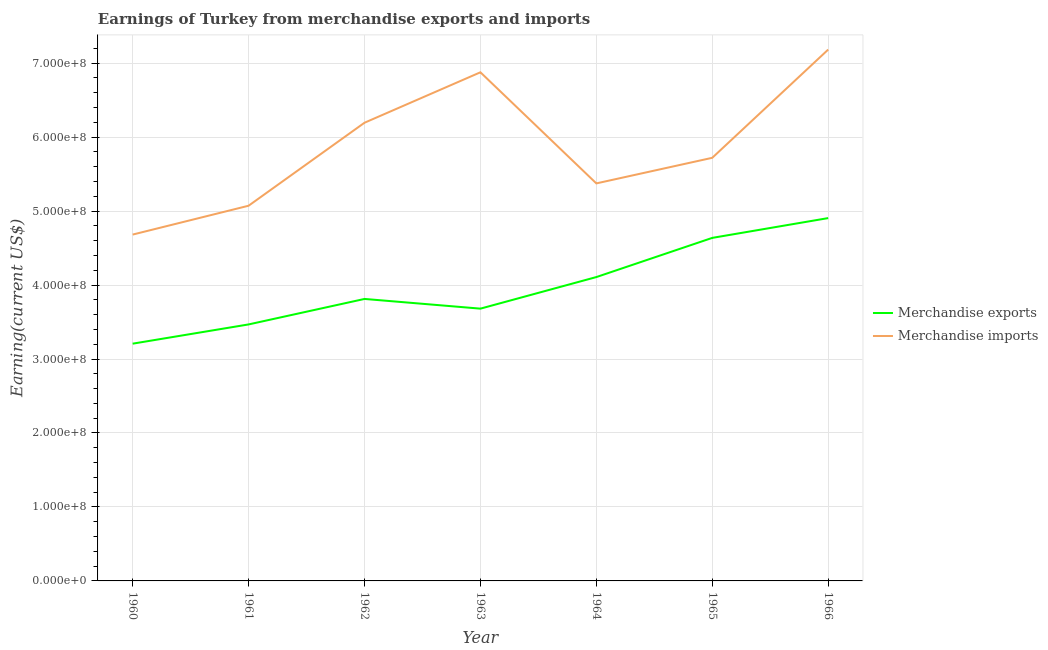Does the line corresponding to earnings from merchandise imports intersect with the line corresponding to earnings from merchandise exports?
Your answer should be very brief. No. Is the number of lines equal to the number of legend labels?
Offer a very short reply. Yes. What is the earnings from merchandise imports in 1963?
Keep it short and to the point. 6.88e+08. Across all years, what is the maximum earnings from merchandise exports?
Your answer should be compact. 4.90e+08. Across all years, what is the minimum earnings from merchandise exports?
Your answer should be compact. 3.21e+08. In which year was the earnings from merchandise imports maximum?
Your response must be concise. 1966. In which year was the earnings from merchandise exports minimum?
Make the answer very short. 1960. What is the total earnings from merchandise imports in the graph?
Provide a succinct answer. 4.11e+09. What is the difference between the earnings from merchandise imports in 1964 and that in 1965?
Your answer should be compact. -3.46e+07. What is the difference between the earnings from merchandise imports in 1966 and the earnings from merchandise exports in 1963?
Your response must be concise. 3.50e+08. What is the average earnings from merchandise exports per year?
Offer a very short reply. 3.97e+08. In the year 1965, what is the difference between the earnings from merchandise imports and earnings from merchandise exports?
Make the answer very short. 1.08e+08. In how many years, is the earnings from merchandise imports greater than 340000000 US$?
Give a very brief answer. 7. What is the ratio of the earnings from merchandise exports in 1961 to that in 1966?
Make the answer very short. 0.71. Is the earnings from merchandise exports in 1960 less than that in 1961?
Your response must be concise. Yes. Is the difference between the earnings from merchandise imports in 1961 and 1963 greater than the difference between the earnings from merchandise exports in 1961 and 1963?
Your answer should be very brief. No. What is the difference between the highest and the second highest earnings from merchandise exports?
Make the answer very short. 2.68e+07. What is the difference between the highest and the lowest earnings from merchandise exports?
Your answer should be very brief. 1.70e+08. How many years are there in the graph?
Offer a very short reply. 7. Where does the legend appear in the graph?
Keep it short and to the point. Center right. How are the legend labels stacked?
Offer a very short reply. Vertical. What is the title of the graph?
Your answer should be compact. Earnings of Turkey from merchandise exports and imports. Does "Money lenders" appear as one of the legend labels in the graph?
Offer a very short reply. No. What is the label or title of the X-axis?
Provide a short and direct response. Year. What is the label or title of the Y-axis?
Your answer should be very brief. Earning(current US$). What is the Earning(current US$) of Merchandise exports in 1960?
Your answer should be very brief. 3.21e+08. What is the Earning(current US$) of Merchandise imports in 1960?
Your answer should be compact. 4.68e+08. What is the Earning(current US$) of Merchandise exports in 1961?
Your answer should be compact. 3.47e+08. What is the Earning(current US$) of Merchandise imports in 1961?
Offer a terse response. 5.07e+08. What is the Earning(current US$) in Merchandise exports in 1962?
Offer a very short reply. 3.81e+08. What is the Earning(current US$) in Merchandise imports in 1962?
Make the answer very short. 6.19e+08. What is the Earning(current US$) in Merchandise exports in 1963?
Provide a succinct answer. 3.68e+08. What is the Earning(current US$) in Merchandise imports in 1963?
Your answer should be very brief. 6.88e+08. What is the Earning(current US$) in Merchandise exports in 1964?
Provide a short and direct response. 4.11e+08. What is the Earning(current US$) of Merchandise imports in 1964?
Give a very brief answer. 5.37e+08. What is the Earning(current US$) of Merchandise exports in 1965?
Provide a short and direct response. 4.64e+08. What is the Earning(current US$) in Merchandise imports in 1965?
Offer a very short reply. 5.72e+08. What is the Earning(current US$) in Merchandise exports in 1966?
Your response must be concise. 4.90e+08. What is the Earning(current US$) of Merchandise imports in 1966?
Provide a short and direct response. 7.18e+08. Across all years, what is the maximum Earning(current US$) in Merchandise exports?
Make the answer very short. 4.90e+08. Across all years, what is the maximum Earning(current US$) of Merchandise imports?
Provide a succinct answer. 7.18e+08. Across all years, what is the minimum Earning(current US$) of Merchandise exports?
Ensure brevity in your answer.  3.21e+08. Across all years, what is the minimum Earning(current US$) of Merchandise imports?
Offer a terse response. 4.68e+08. What is the total Earning(current US$) in Merchandise exports in the graph?
Give a very brief answer. 2.78e+09. What is the total Earning(current US$) in Merchandise imports in the graph?
Offer a very short reply. 4.11e+09. What is the difference between the Earning(current US$) of Merchandise exports in 1960 and that in 1961?
Your response must be concise. -2.60e+07. What is the difference between the Earning(current US$) of Merchandise imports in 1960 and that in 1961?
Provide a short and direct response. -3.90e+07. What is the difference between the Earning(current US$) in Merchandise exports in 1960 and that in 1962?
Your response must be concise. -6.05e+07. What is the difference between the Earning(current US$) in Merchandise imports in 1960 and that in 1962?
Keep it short and to the point. -1.51e+08. What is the difference between the Earning(current US$) in Merchandise exports in 1960 and that in 1963?
Your response must be concise. -4.74e+07. What is the difference between the Earning(current US$) in Merchandise imports in 1960 and that in 1963?
Give a very brief answer. -2.19e+08. What is the difference between the Earning(current US$) of Merchandise exports in 1960 and that in 1964?
Offer a very short reply. -9.00e+07. What is the difference between the Earning(current US$) of Merchandise imports in 1960 and that in 1964?
Ensure brevity in your answer.  -6.92e+07. What is the difference between the Earning(current US$) in Merchandise exports in 1960 and that in 1965?
Provide a succinct answer. -1.43e+08. What is the difference between the Earning(current US$) in Merchandise imports in 1960 and that in 1965?
Give a very brief answer. -1.04e+08. What is the difference between the Earning(current US$) in Merchandise exports in 1960 and that in 1966?
Keep it short and to the point. -1.70e+08. What is the difference between the Earning(current US$) in Merchandise imports in 1960 and that in 1966?
Your response must be concise. -2.50e+08. What is the difference between the Earning(current US$) in Merchandise exports in 1961 and that in 1962?
Offer a terse response. -3.45e+07. What is the difference between the Earning(current US$) in Merchandise imports in 1961 and that in 1962?
Your answer should be compact. -1.12e+08. What is the difference between the Earning(current US$) in Merchandise exports in 1961 and that in 1963?
Keep it short and to the point. -2.14e+07. What is the difference between the Earning(current US$) of Merchandise imports in 1961 and that in 1963?
Your response must be concise. -1.80e+08. What is the difference between the Earning(current US$) of Merchandise exports in 1961 and that in 1964?
Your response must be concise. -6.40e+07. What is the difference between the Earning(current US$) of Merchandise imports in 1961 and that in 1964?
Your answer should be very brief. -3.02e+07. What is the difference between the Earning(current US$) in Merchandise exports in 1961 and that in 1965?
Offer a very short reply. -1.17e+08. What is the difference between the Earning(current US$) of Merchandise imports in 1961 and that in 1965?
Your response must be concise. -6.48e+07. What is the difference between the Earning(current US$) in Merchandise exports in 1961 and that in 1966?
Ensure brevity in your answer.  -1.44e+08. What is the difference between the Earning(current US$) in Merchandise imports in 1961 and that in 1966?
Give a very brief answer. -2.11e+08. What is the difference between the Earning(current US$) of Merchandise exports in 1962 and that in 1963?
Give a very brief answer. 1.31e+07. What is the difference between the Earning(current US$) of Merchandise imports in 1962 and that in 1963?
Your answer should be compact. -6.82e+07. What is the difference between the Earning(current US$) in Merchandise exports in 1962 and that in 1964?
Provide a short and direct response. -2.96e+07. What is the difference between the Earning(current US$) in Merchandise imports in 1962 and that in 1964?
Your response must be concise. 8.20e+07. What is the difference between the Earning(current US$) of Merchandise exports in 1962 and that in 1965?
Offer a very short reply. -8.25e+07. What is the difference between the Earning(current US$) of Merchandise imports in 1962 and that in 1965?
Make the answer very short. 4.74e+07. What is the difference between the Earning(current US$) in Merchandise exports in 1962 and that in 1966?
Ensure brevity in your answer.  -1.09e+08. What is the difference between the Earning(current US$) in Merchandise imports in 1962 and that in 1966?
Your answer should be compact. -9.89e+07. What is the difference between the Earning(current US$) of Merchandise exports in 1963 and that in 1964?
Your answer should be very brief. -4.27e+07. What is the difference between the Earning(current US$) in Merchandise imports in 1963 and that in 1964?
Keep it short and to the point. 1.50e+08. What is the difference between the Earning(current US$) of Merchandise exports in 1963 and that in 1965?
Your answer should be very brief. -9.56e+07. What is the difference between the Earning(current US$) in Merchandise imports in 1963 and that in 1965?
Keep it short and to the point. 1.16e+08. What is the difference between the Earning(current US$) of Merchandise exports in 1963 and that in 1966?
Your response must be concise. -1.22e+08. What is the difference between the Earning(current US$) in Merchandise imports in 1963 and that in 1966?
Keep it short and to the point. -3.07e+07. What is the difference between the Earning(current US$) of Merchandise exports in 1964 and that in 1965?
Make the answer very short. -5.30e+07. What is the difference between the Earning(current US$) in Merchandise imports in 1964 and that in 1965?
Your response must be concise. -3.46e+07. What is the difference between the Earning(current US$) of Merchandise exports in 1964 and that in 1966?
Ensure brevity in your answer.  -7.97e+07. What is the difference between the Earning(current US$) in Merchandise imports in 1964 and that in 1966?
Provide a short and direct response. -1.81e+08. What is the difference between the Earning(current US$) of Merchandise exports in 1965 and that in 1966?
Make the answer very short. -2.68e+07. What is the difference between the Earning(current US$) of Merchandise imports in 1965 and that in 1966?
Your answer should be compact. -1.46e+08. What is the difference between the Earning(current US$) in Merchandise exports in 1960 and the Earning(current US$) in Merchandise imports in 1961?
Give a very brief answer. -1.86e+08. What is the difference between the Earning(current US$) in Merchandise exports in 1960 and the Earning(current US$) in Merchandise imports in 1962?
Offer a very short reply. -2.99e+08. What is the difference between the Earning(current US$) of Merchandise exports in 1960 and the Earning(current US$) of Merchandise imports in 1963?
Give a very brief answer. -3.67e+08. What is the difference between the Earning(current US$) in Merchandise exports in 1960 and the Earning(current US$) in Merchandise imports in 1964?
Keep it short and to the point. -2.17e+08. What is the difference between the Earning(current US$) of Merchandise exports in 1960 and the Earning(current US$) of Merchandise imports in 1965?
Your answer should be very brief. -2.51e+08. What is the difference between the Earning(current US$) of Merchandise exports in 1960 and the Earning(current US$) of Merchandise imports in 1966?
Your response must be concise. -3.98e+08. What is the difference between the Earning(current US$) of Merchandise exports in 1961 and the Earning(current US$) of Merchandise imports in 1962?
Make the answer very short. -2.73e+08. What is the difference between the Earning(current US$) in Merchandise exports in 1961 and the Earning(current US$) in Merchandise imports in 1963?
Make the answer very short. -3.41e+08. What is the difference between the Earning(current US$) of Merchandise exports in 1961 and the Earning(current US$) of Merchandise imports in 1964?
Your answer should be very brief. -1.91e+08. What is the difference between the Earning(current US$) in Merchandise exports in 1961 and the Earning(current US$) in Merchandise imports in 1965?
Keep it short and to the point. -2.25e+08. What is the difference between the Earning(current US$) in Merchandise exports in 1961 and the Earning(current US$) in Merchandise imports in 1966?
Your answer should be very brief. -3.72e+08. What is the difference between the Earning(current US$) of Merchandise exports in 1962 and the Earning(current US$) of Merchandise imports in 1963?
Provide a succinct answer. -3.06e+08. What is the difference between the Earning(current US$) of Merchandise exports in 1962 and the Earning(current US$) of Merchandise imports in 1964?
Offer a terse response. -1.56e+08. What is the difference between the Earning(current US$) of Merchandise exports in 1962 and the Earning(current US$) of Merchandise imports in 1965?
Provide a short and direct response. -1.91e+08. What is the difference between the Earning(current US$) in Merchandise exports in 1962 and the Earning(current US$) in Merchandise imports in 1966?
Keep it short and to the point. -3.37e+08. What is the difference between the Earning(current US$) in Merchandise exports in 1963 and the Earning(current US$) in Merchandise imports in 1964?
Your response must be concise. -1.69e+08. What is the difference between the Earning(current US$) in Merchandise exports in 1963 and the Earning(current US$) in Merchandise imports in 1965?
Give a very brief answer. -2.04e+08. What is the difference between the Earning(current US$) of Merchandise exports in 1963 and the Earning(current US$) of Merchandise imports in 1966?
Give a very brief answer. -3.50e+08. What is the difference between the Earning(current US$) of Merchandise exports in 1964 and the Earning(current US$) of Merchandise imports in 1965?
Offer a terse response. -1.61e+08. What is the difference between the Earning(current US$) of Merchandise exports in 1964 and the Earning(current US$) of Merchandise imports in 1966?
Provide a short and direct response. -3.08e+08. What is the difference between the Earning(current US$) of Merchandise exports in 1965 and the Earning(current US$) of Merchandise imports in 1966?
Your answer should be compact. -2.55e+08. What is the average Earning(current US$) of Merchandise exports per year?
Give a very brief answer. 3.97e+08. What is the average Earning(current US$) in Merchandise imports per year?
Provide a short and direct response. 5.87e+08. In the year 1960, what is the difference between the Earning(current US$) of Merchandise exports and Earning(current US$) of Merchandise imports?
Make the answer very short. -1.47e+08. In the year 1961, what is the difference between the Earning(current US$) of Merchandise exports and Earning(current US$) of Merchandise imports?
Provide a succinct answer. -1.60e+08. In the year 1962, what is the difference between the Earning(current US$) of Merchandise exports and Earning(current US$) of Merchandise imports?
Provide a short and direct response. -2.38e+08. In the year 1963, what is the difference between the Earning(current US$) of Merchandise exports and Earning(current US$) of Merchandise imports?
Offer a very short reply. -3.20e+08. In the year 1964, what is the difference between the Earning(current US$) in Merchandise exports and Earning(current US$) in Merchandise imports?
Your answer should be compact. -1.27e+08. In the year 1965, what is the difference between the Earning(current US$) in Merchandise exports and Earning(current US$) in Merchandise imports?
Ensure brevity in your answer.  -1.08e+08. In the year 1966, what is the difference between the Earning(current US$) of Merchandise exports and Earning(current US$) of Merchandise imports?
Provide a succinct answer. -2.28e+08. What is the ratio of the Earning(current US$) in Merchandise exports in 1960 to that in 1961?
Your answer should be very brief. 0.93. What is the ratio of the Earning(current US$) in Merchandise imports in 1960 to that in 1961?
Your answer should be very brief. 0.92. What is the ratio of the Earning(current US$) of Merchandise exports in 1960 to that in 1962?
Your response must be concise. 0.84. What is the ratio of the Earning(current US$) of Merchandise imports in 1960 to that in 1962?
Your answer should be compact. 0.76. What is the ratio of the Earning(current US$) of Merchandise exports in 1960 to that in 1963?
Provide a succinct answer. 0.87. What is the ratio of the Earning(current US$) in Merchandise imports in 1960 to that in 1963?
Ensure brevity in your answer.  0.68. What is the ratio of the Earning(current US$) of Merchandise exports in 1960 to that in 1964?
Give a very brief answer. 0.78. What is the ratio of the Earning(current US$) in Merchandise imports in 1960 to that in 1964?
Offer a very short reply. 0.87. What is the ratio of the Earning(current US$) of Merchandise exports in 1960 to that in 1965?
Offer a very short reply. 0.69. What is the ratio of the Earning(current US$) in Merchandise imports in 1960 to that in 1965?
Offer a terse response. 0.82. What is the ratio of the Earning(current US$) of Merchandise exports in 1960 to that in 1966?
Provide a short and direct response. 0.65. What is the ratio of the Earning(current US$) of Merchandise imports in 1960 to that in 1966?
Your response must be concise. 0.65. What is the ratio of the Earning(current US$) in Merchandise exports in 1961 to that in 1962?
Offer a very short reply. 0.91. What is the ratio of the Earning(current US$) in Merchandise imports in 1961 to that in 1962?
Provide a succinct answer. 0.82. What is the ratio of the Earning(current US$) in Merchandise exports in 1961 to that in 1963?
Keep it short and to the point. 0.94. What is the ratio of the Earning(current US$) in Merchandise imports in 1961 to that in 1963?
Provide a short and direct response. 0.74. What is the ratio of the Earning(current US$) in Merchandise exports in 1961 to that in 1964?
Give a very brief answer. 0.84. What is the ratio of the Earning(current US$) in Merchandise imports in 1961 to that in 1964?
Keep it short and to the point. 0.94. What is the ratio of the Earning(current US$) of Merchandise exports in 1961 to that in 1965?
Provide a succinct answer. 0.75. What is the ratio of the Earning(current US$) of Merchandise imports in 1961 to that in 1965?
Ensure brevity in your answer.  0.89. What is the ratio of the Earning(current US$) in Merchandise exports in 1961 to that in 1966?
Offer a terse response. 0.71. What is the ratio of the Earning(current US$) of Merchandise imports in 1961 to that in 1966?
Your response must be concise. 0.71. What is the ratio of the Earning(current US$) in Merchandise exports in 1962 to that in 1963?
Your answer should be compact. 1.04. What is the ratio of the Earning(current US$) in Merchandise imports in 1962 to that in 1963?
Provide a short and direct response. 0.9. What is the ratio of the Earning(current US$) in Merchandise exports in 1962 to that in 1964?
Ensure brevity in your answer.  0.93. What is the ratio of the Earning(current US$) in Merchandise imports in 1962 to that in 1964?
Your answer should be compact. 1.15. What is the ratio of the Earning(current US$) of Merchandise exports in 1962 to that in 1965?
Your answer should be very brief. 0.82. What is the ratio of the Earning(current US$) in Merchandise imports in 1962 to that in 1965?
Provide a short and direct response. 1.08. What is the ratio of the Earning(current US$) in Merchandise exports in 1962 to that in 1966?
Ensure brevity in your answer.  0.78. What is the ratio of the Earning(current US$) in Merchandise imports in 1962 to that in 1966?
Keep it short and to the point. 0.86. What is the ratio of the Earning(current US$) in Merchandise exports in 1963 to that in 1964?
Give a very brief answer. 0.9. What is the ratio of the Earning(current US$) in Merchandise imports in 1963 to that in 1964?
Keep it short and to the point. 1.28. What is the ratio of the Earning(current US$) in Merchandise exports in 1963 to that in 1965?
Provide a short and direct response. 0.79. What is the ratio of the Earning(current US$) in Merchandise imports in 1963 to that in 1965?
Your answer should be very brief. 1.2. What is the ratio of the Earning(current US$) of Merchandise exports in 1963 to that in 1966?
Provide a succinct answer. 0.75. What is the ratio of the Earning(current US$) of Merchandise imports in 1963 to that in 1966?
Make the answer very short. 0.96. What is the ratio of the Earning(current US$) in Merchandise exports in 1964 to that in 1965?
Provide a succinct answer. 0.89. What is the ratio of the Earning(current US$) of Merchandise imports in 1964 to that in 1965?
Make the answer very short. 0.94. What is the ratio of the Earning(current US$) in Merchandise exports in 1964 to that in 1966?
Provide a short and direct response. 0.84. What is the ratio of the Earning(current US$) of Merchandise imports in 1964 to that in 1966?
Provide a succinct answer. 0.75. What is the ratio of the Earning(current US$) of Merchandise exports in 1965 to that in 1966?
Keep it short and to the point. 0.95. What is the ratio of the Earning(current US$) in Merchandise imports in 1965 to that in 1966?
Make the answer very short. 0.8. What is the difference between the highest and the second highest Earning(current US$) in Merchandise exports?
Provide a succinct answer. 2.68e+07. What is the difference between the highest and the second highest Earning(current US$) of Merchandise imports?
Give a very brief answer. 3.07e+07. What is the difference between the highest and the lowest Earning(current US$) of Merchandise exports?
Offer a very short reply. 1.70e+08. What is the difference between the highest and the lowest Earning(current US$) in Merchandise imports?
Provide a succinct answer. 2.50e+08. 